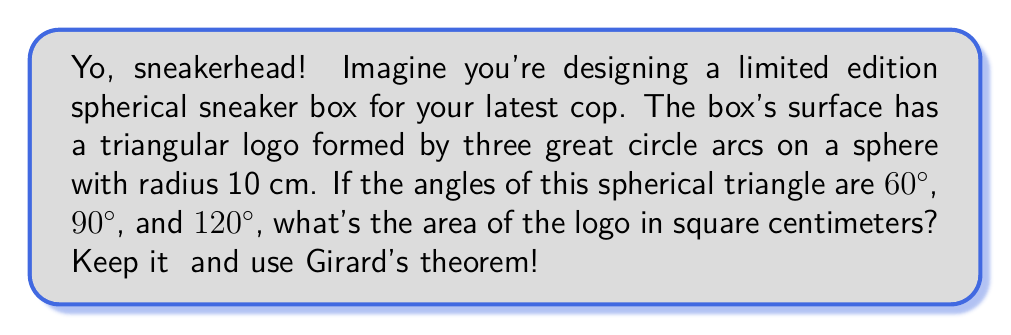Teach me how to tackle this problem. Let's break it down step by step:

1) First, recall Girard's theorem for spherical triangles:
   $$A = R^2(α + β + γ - π)$$
   where A is the area, R is the radius of the sphere, and α, β, γ are the angles of the spherical triangle in radians.

2) We're given the angles in degrees, so let's convert them to radians:
   60° = $\frac{\pi}{3}$ rad
   90° = $\frac{\pi}{2}$ rad
   120° = $\frac{2\pi}{3}$ rad

3) Now, let's sum up the angles:
   $$α + β + γ = \frac{\pi}{3} + \frac{\pi}{2} + \frac{2\pi}{3} = \frac{3\pi}{2}$$

4) Subtract π from this sum:
   $$\frac{3\pi}{2} - π = \frac{\pi}{2}$$

5) Now we can plug everything into Girard's theorem:
   $$A = R^2(α + β + γ - π) = 10^2 \cdot \frac{\pi}{2} = 50π$$

6) This gives us the area in square centimeters.
Answer: $50π$ cm² 